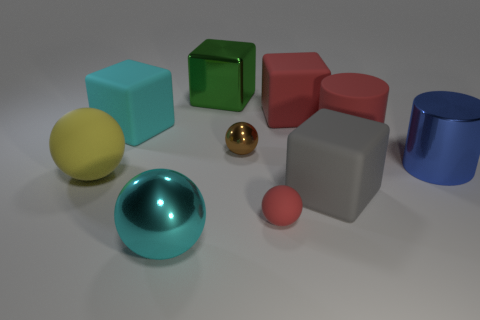Is the material of the large gray block the same as the large block on the left side of the green shiny block?
Offer a very short reply. Yes. Is there a small matte object of the same shape as the green shiny thing?
Ensure brevity in your answer.  No. There is a red thing that is the same size as the brown thing; what is its material?
Provide a succinct answer. Rubber. How big is the yellow matte sphere that is in front of the tiny shiny ball?
Offer a very short reply. Large. There is a cyan object behind the gray block; is its size the same as the rubber ball that is behind the red matte ball?
Ensure brevity in your answer.  Yes. How many big blue objects are the same material as the big yellow thing?
Keep it short and to the point. 0. The rubber cylinder is what color?
Make the answer very short. Red. There is a large green block; are there any large matte balls behind it?
Your answer should be compact. No. Does the tiny shiny object have the same color as the shiny cube?
Your answer should be compact. No. What number of large rubber cubes are the same color as the small matte sphere?
Offer a terse response. 1. 